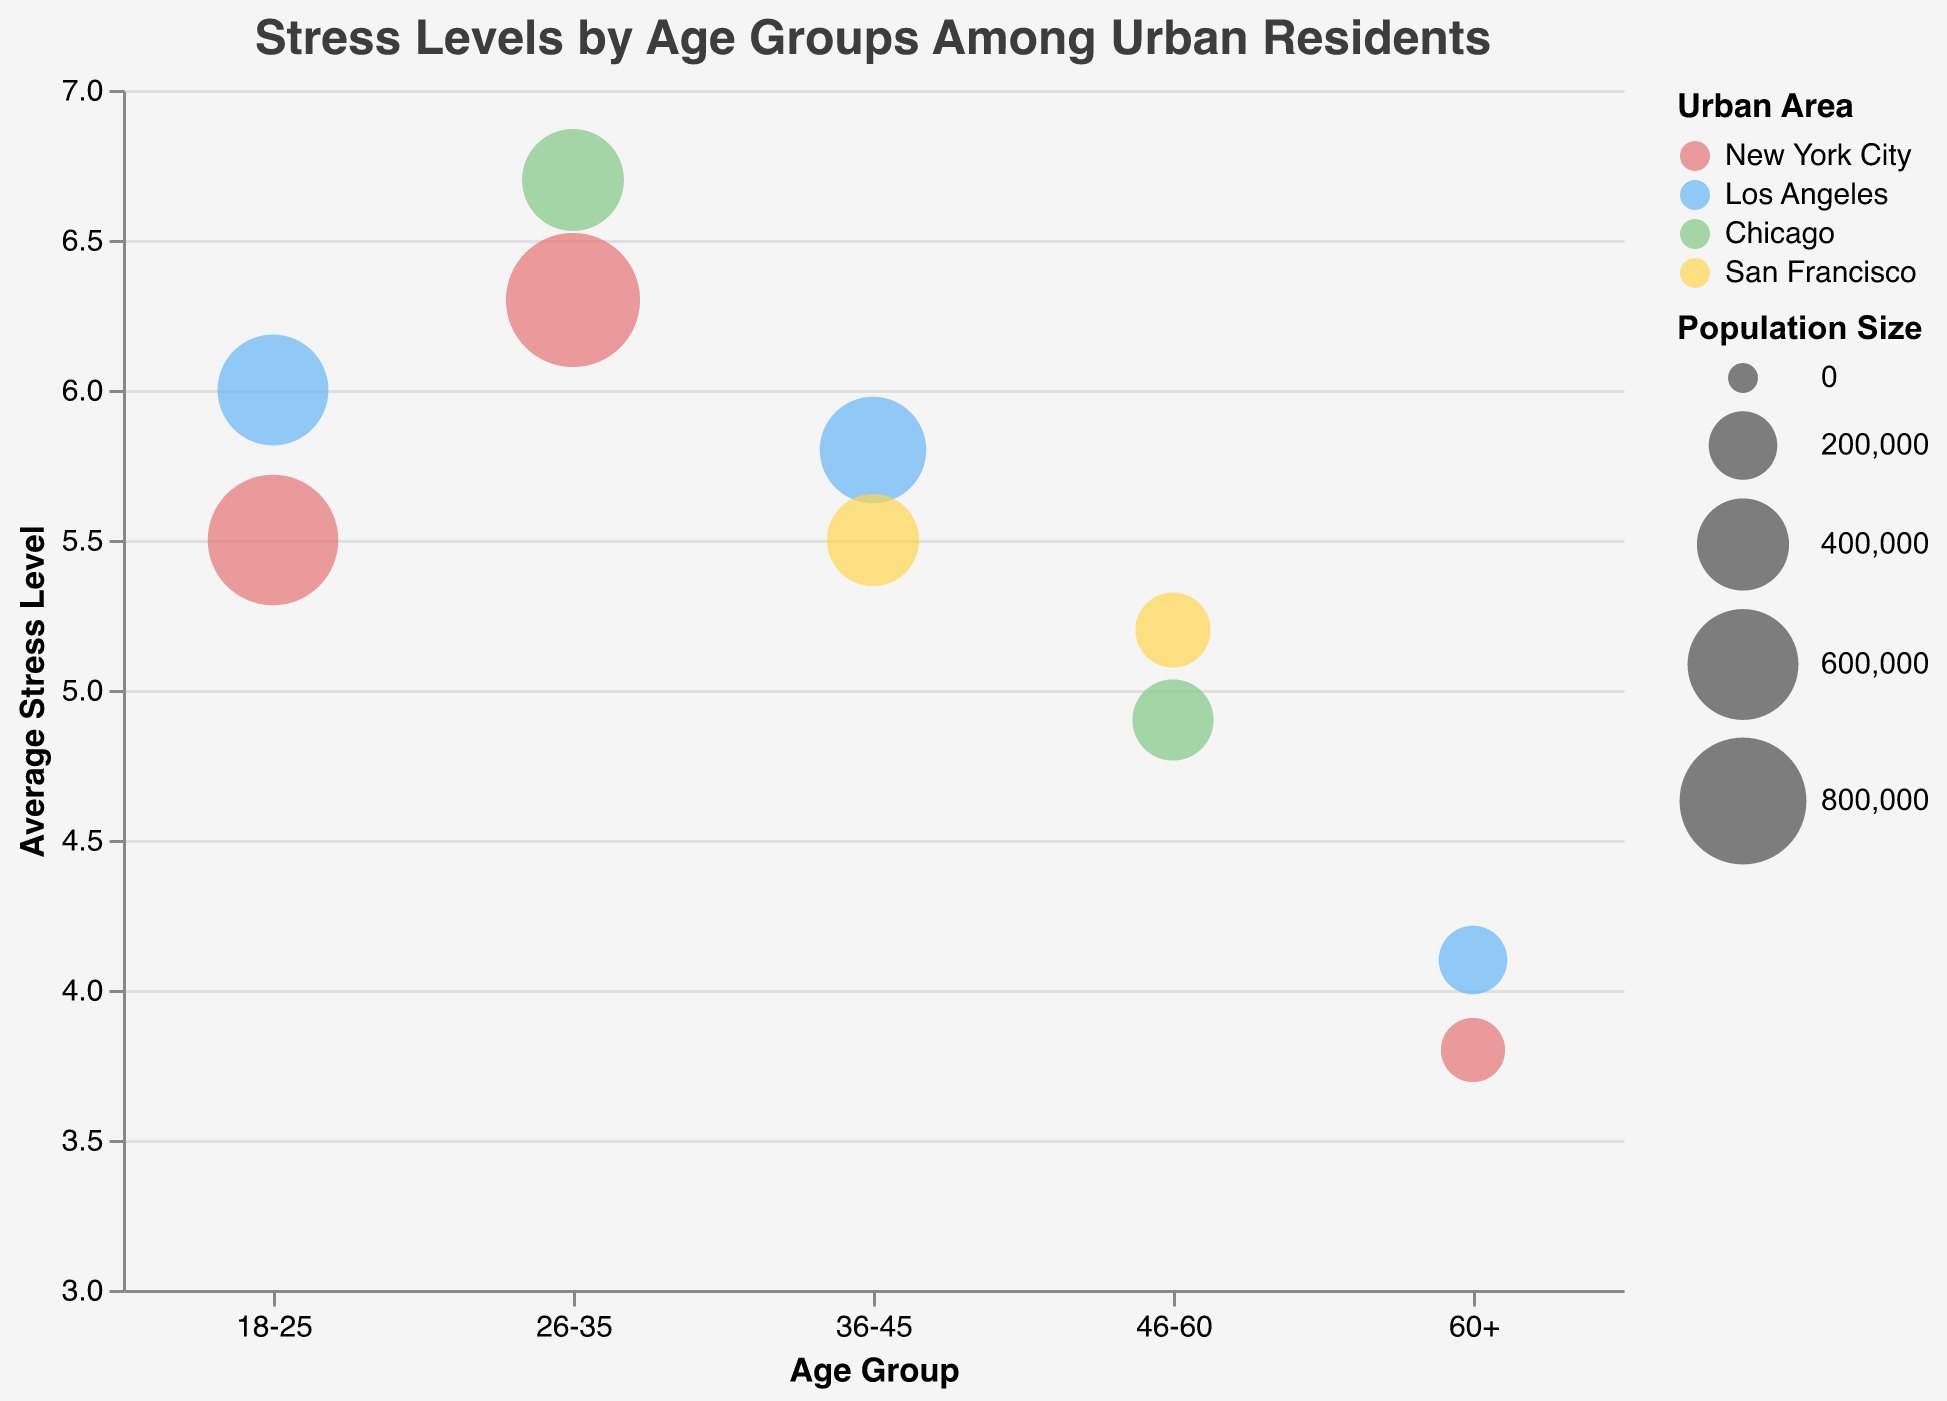Which age group has the highest average stress level? By looking at the y-axis and finding the highest point on the graph, we can see that the age group 26-35 has the highest average stress level of 6.7.
Answer: 26-35 What is the average stress level for residents aged 60+ in New York City? By checking the data points and the tooltips associated with the age group 60+, you see that the average stress level for New York City is 3.8.
Answer: 3.8 Compare the average stress level of residents aged 36-45 in Los Angeles and San Francisco. Which city has a higher stress level? For the age group 36-45, Los Angeles has an average stress level of 5.8, and San Francisco has an average stress level of 5.5. Since 5.8 is greater than 5.5, Los Angeles has a higher stress level.
Answer: Los Angeles How does the average stress level of residents aged 46-60 in Chicago compare to San Francisco? Checking the data points for the age group 46-60, Chicago has an average stress level of 4.9, whereas San Francisco has 5.2. Since 5.2 is greater than 4.9, San Francisco has a higher stress level.
Answer: San Francisco Which urban area has the largest population size for the age group 26-35? Looking at the size of the bubbles, the largest bubble for the age group 26-35 is in New York City, with a population size of 900,000.
Answer: New York City What is the overall trend in average stress levels as age increases? Observing the bubbles from left to right (younger to older age groups), the average stress levels roughly decrease as age increases. For example, the average stress level falls from 6.3 in the 26-35 age group to 4.1 in the 60+ age group.
Answer: Decreases Which population group has the smallest bubble on the chart, and what does this represent? A careful examination of the chart reveals that the smallest bubble represents the 60+ age group in New York City with a population size of 170,000.
Answer: 60+ in New York City How much higher is the average stress level for the 18-25 age group in Los Angeles compared to New York City? For the 18-25 age group, the average stress level in New York City is 5.5, and in Los Angeles, it is 6.0. The difference is 6.0 - 5.5 = 0.5.
Answer: 0.5 What is the color coding used for the different urban areas on the bubble chart? Observing the bubble colors, New York City is red, Los Angeles is blue, Chicago is green, and San Francisco is yellow.
Answer: New York City red, Los Angeles blue, Chicago green, San Francisco yellow 